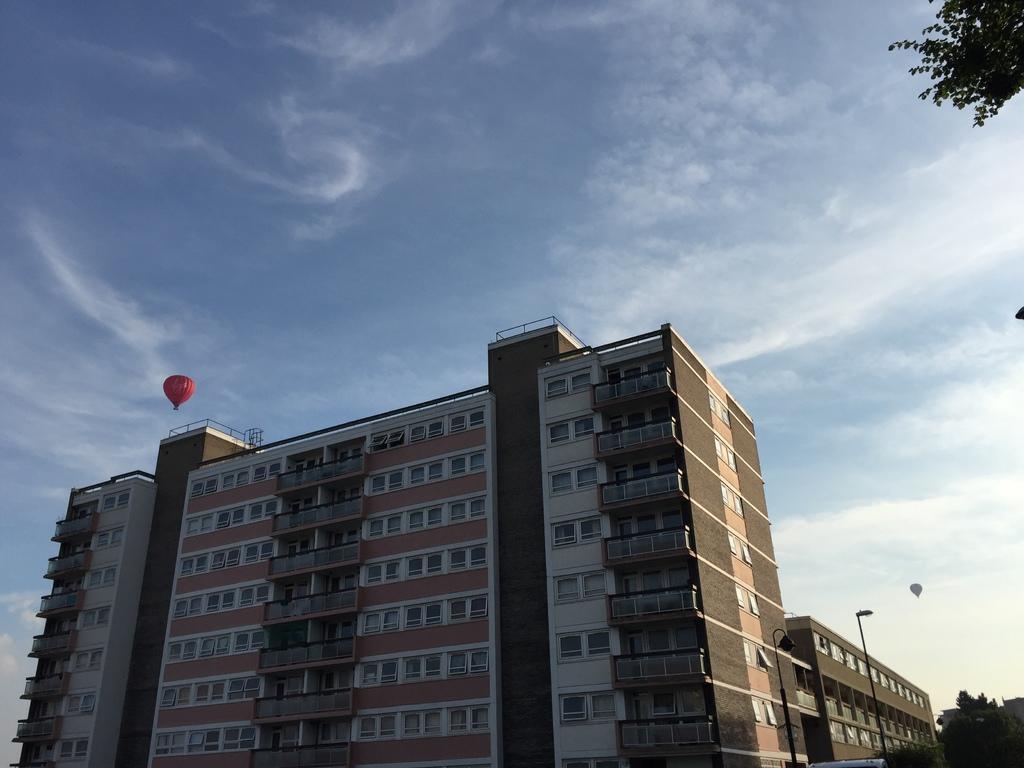In one or two sentences, can you explain what this image depicts? In this picture we can see buildings and trees, here we can see poles, parachutes and in the background we can see the sky. 